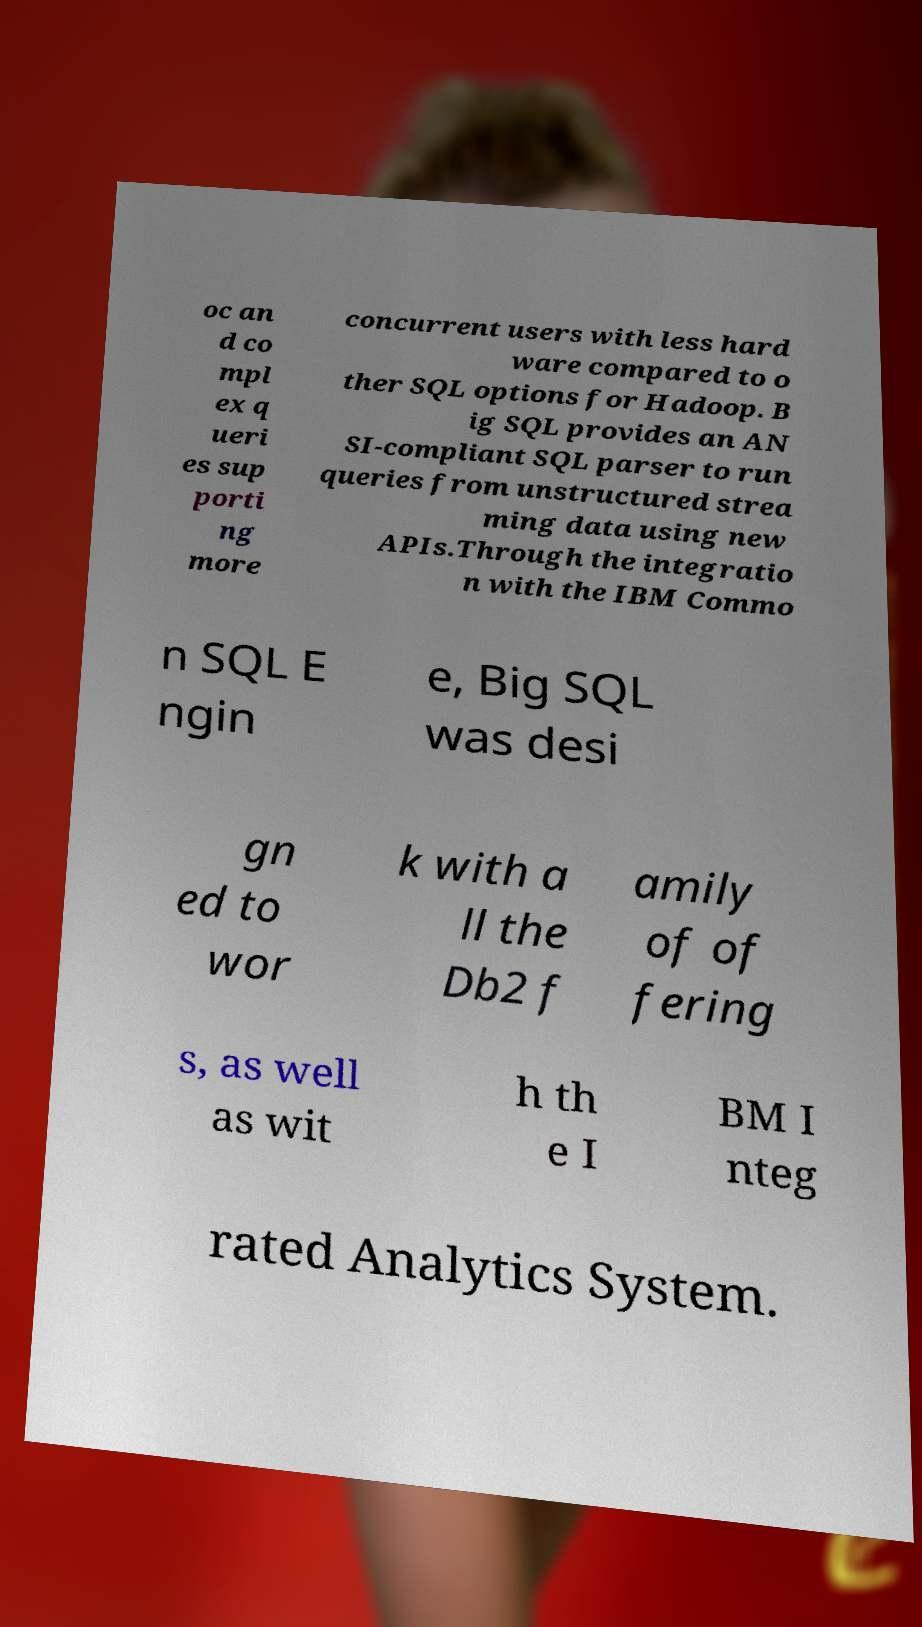I need the written content from this picture converted into text. Can you do that? oc an d co mpl ex q ueri es sup porti ng more concurrent users with less hard ware compared to o ther SQL options for Hadoop. B ig SQL provides an AN SI-compliant SQL parser to run queries from unstructured strea ming data using new APIs.Through the integratio n with the IBM Commo n SQL E ngin e, Big SQL was desi gn ed to wor k with a ll the Db2 f amily of of fering s, as well as wit h th e I BM I nteg rated Analytics System. 